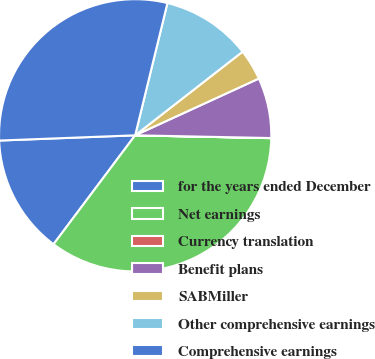<chart> <loc_0><loc_0><loc_500><loc_500><pie_chart><fcel>for the years ended December<fcel>Net earnings<fcel>Currency translation<fcel>Benefit plans<fcel>SABMiller<fcel>Other comprehensive earnings<fcel>Comprehensive earnings<nl><fcel>14.15%<fcel>34.9%<fcel>0.01%<fcel>7.17%<fcel>3.68%<fcel>10.66%<fcel>29.42%<nl></chart> 